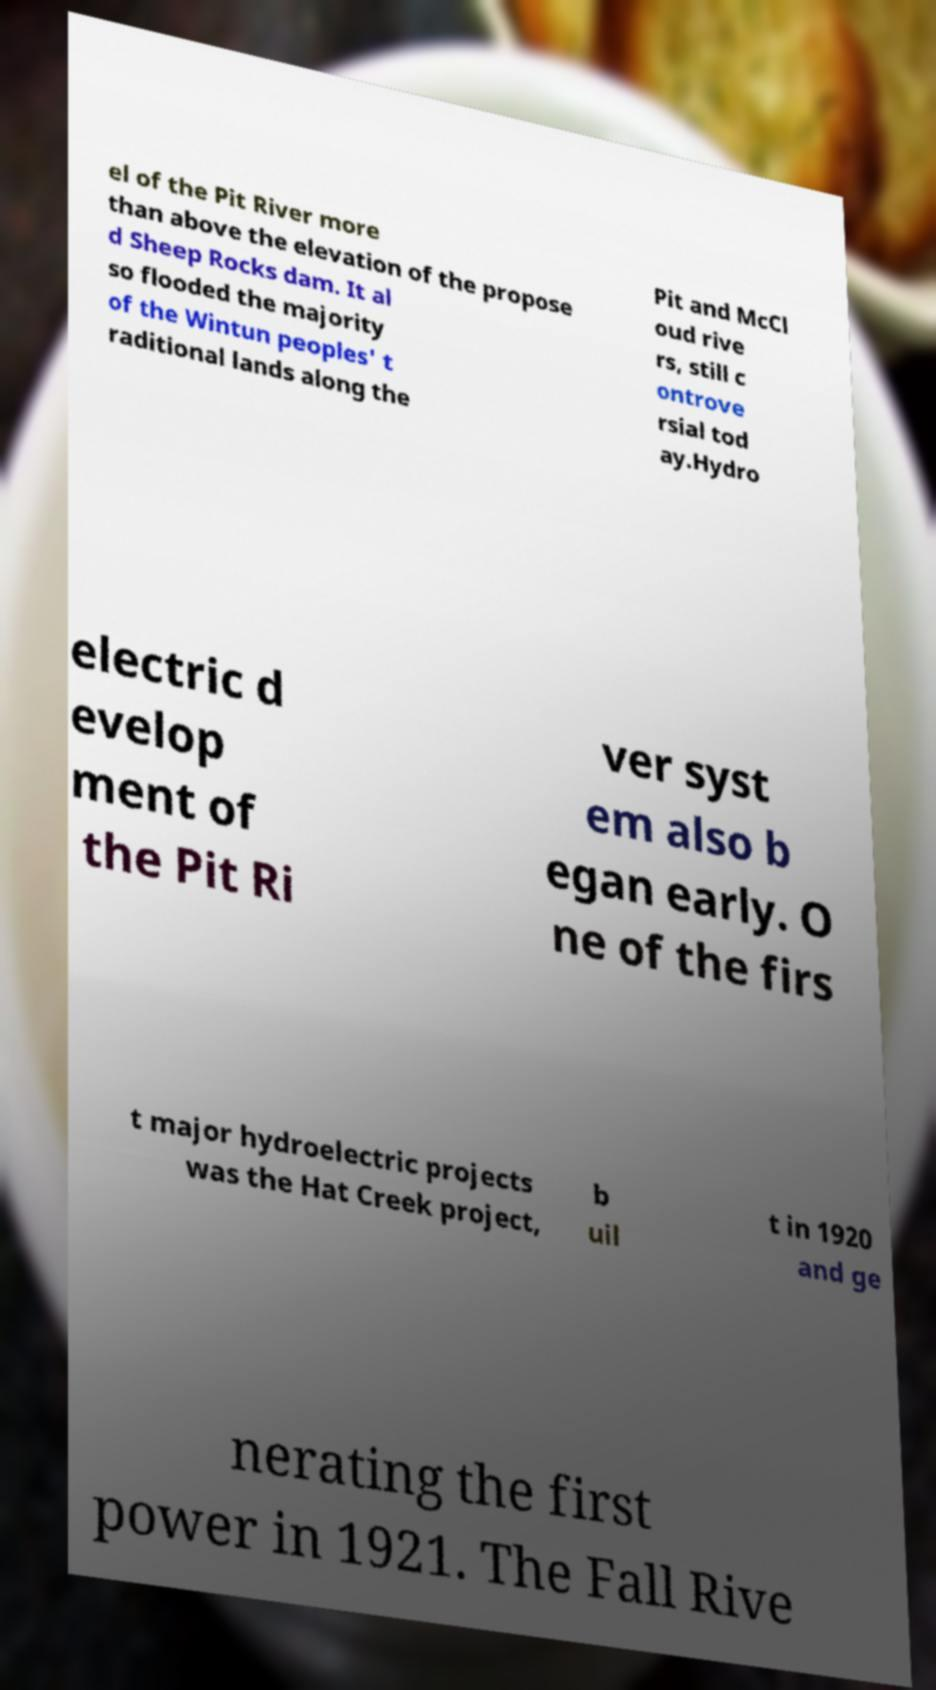Please identify and transcribe the text found in this image. el of the Pit River more than above the elevation of the propose d Sheep Rocks dam. It al so flooded the majority of the Wintun peoples' t raditional lands along the Pit and McCl oud rive rs, still c ontrove rsial tod ay.Hydro electric d evelop ment of the Pit Ri ver syst em also b egan early. O ne of the firs t major hydroelectric projects was the Hat Creek project, b uil t in 1920 and ge nerating the first power in 1921. The Fall Rive 